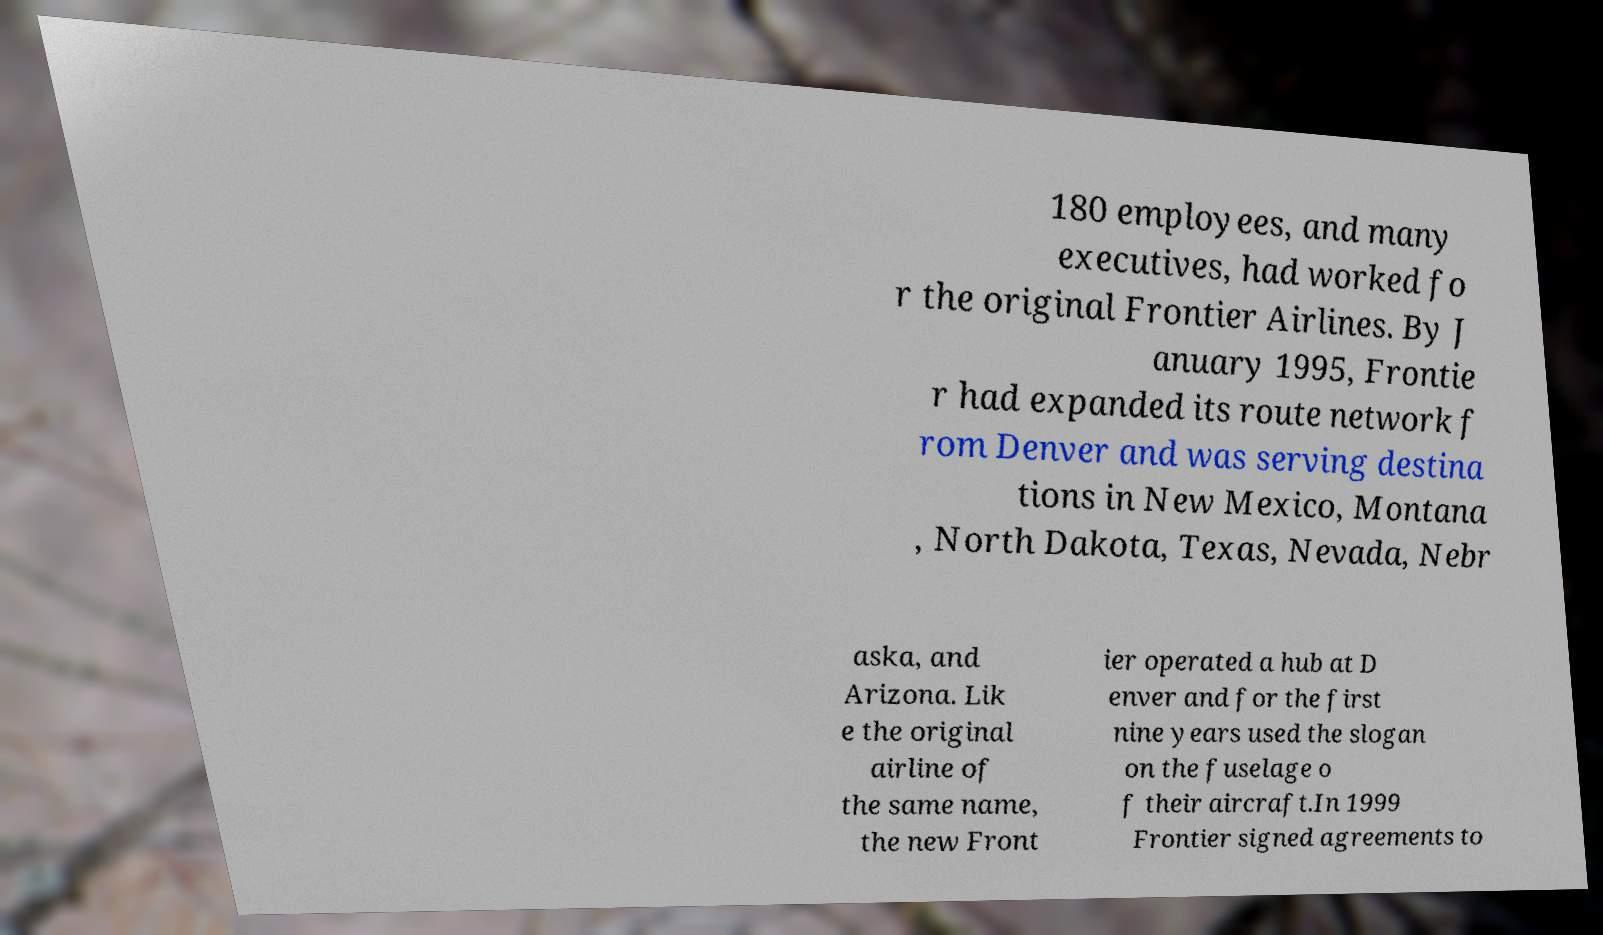I need the written content from this picture converted into text. Can you do that? 180 employees, and many executives, had worked fo r the original Frontier Airlines. By J anuary 1995, Frontie r had expanded its route network f rom Denver and was serving destina tions in New Mexico, Montana , North Dakota, Texas, Nevada, Nebr aska, and Arizona. Lik e the original airline of the same name, the new Front ier operated a hub at D enver and for the first nine years used the slogan on the fuselage o f their aircraft.In 1999 Frontier signed agreements to 